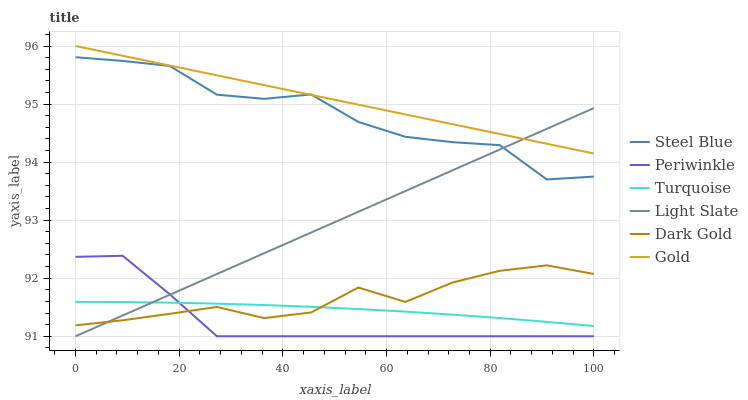Does Periwinkle have the minimum area under the curve?
Answer yes or no. Yes. Does Gold have the maximum area under the curve?
Answer yes or no. Yes. Does Dark Gold have the minimum area under the curve?
Answer yes or no. No. Does Dark Gold have the maximum area under the curve?
Answer yes or no. No. Is Light Slate the smoothest?
Answer yes or no. Yes. Is Steel Blue the roughest?
Answer yes or no. Yes. Is Gold the smoothest?
Answer yes or no. No. Is Gold the roughest?
Answer yes or no. No. Does Light Slate have the lowest value?
Answer yes or no. Yes. Does Dark Gold have the lowest value?
Answer yes or no. No. Does Gold have the highest value?
Answer yes or no. Yes. Does Dark Gold have the highest value?
Answer yes or no. No. Is Turquoise less than Steel Blue?
Answer yes or no. Yes. Is Gold greater than Dark Gold?
Answer yes or no. Yes. Does Gold intersect Light Slate?
Answer yes or no. Yes. Is Gold less than Light Slate?
Answer yes or no. No. Is Gold greater than Light Slate?
Answer yes or no. No. Does Turquoise intersect Steel Blue?
Answer yes or no. No. 